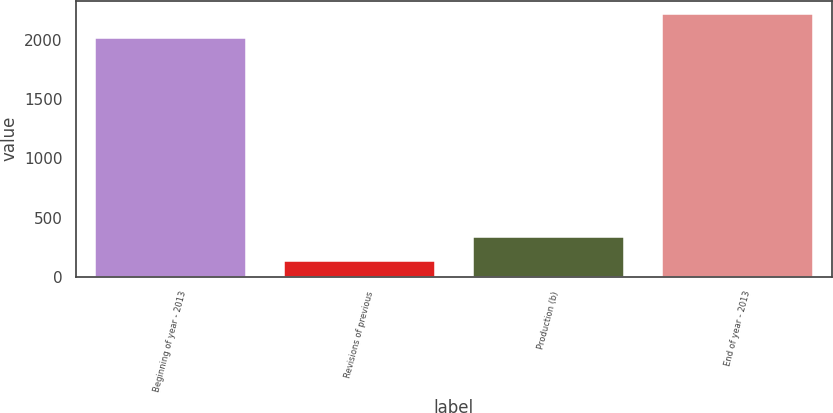<chart> <loc_0><loc_0><loc_500><loc_500><bar_chart><fcel>Beginning of year - 2013<fcel>Revisions of previous<fcel>Production (b)<fcel>End of year - 2013<nl><fcel>2017<fcel>132<fcel>335.9<fcel>2220.9<nl></chart> 